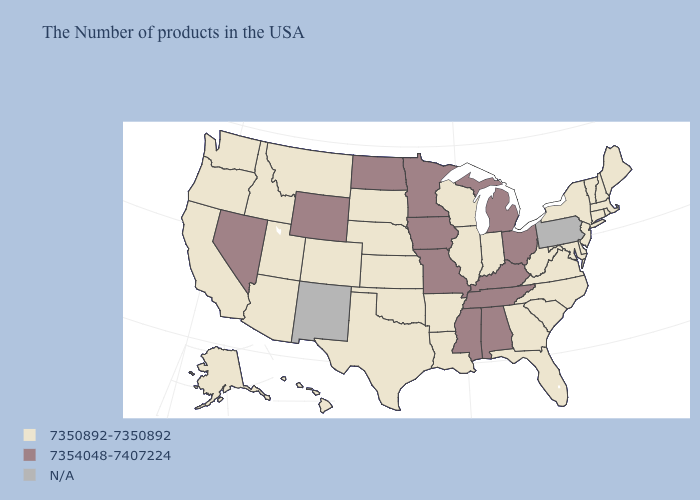Name the states that have a value in the range 7350892-7350892?
Quick response, please. Maine, Massachusetts, Rhode Island, New Hampshire, Vermont, Connecticut, New York, New Jersey, Delaware, Maryland, Virginia, North Carolina, South Carolina, West Virginia, Florida, Georgia, Indiana, Wisconsin, Illinois, Louisiana, Arkansas, Kansas, Nebraska, Oklahoma, Texas, South Dakota, Colorado, Utah, Montana, Arizona, Idaho, California, Washington, Oregon, Alaska, Hawaii. What is the value of Florida?
Short answer required. 7350892-7350892. What is the lowest value in states that border Connecticut?
Be succinct. 7350892-7350892. Which states have the highest value in the USA?
Be succinct. Ohio, Michigan, Kentucky, Alabama, Tennessee, Mississippi, Missouri, Minnesota, Iowa, North Dakota, Wyoming, Nevada. Among the states that border Michigan , which have the lowest value?
Answer briefly. Indiana, Wisconsin. Name the states that have a value in the range N/A?
Concise answer only. Pennsylvania, New Mexico. Among the states that border Idaho , does Utah have the highest value?
Be succinct. No. Name the states that have a value in the range N/A?
Write a very short answer. Pennsylvania, New Mexico. Name the states that have a value in the range 7354048-7407224?
Keep it brief. Ohio, Michigan, Kentucky, Alabama, Tennessee, Mississippi, Missouri, Minnesota, Iowa, North Dakota, Wyoming, Nevada. What is the value of Iowa?
Quick response, please. 7354048-7407224. What is the value of New Jersey?
Write a very short answer. 7350892-7350892. Name the states that have a value in the range N/A?
Be succinct. Pennsylvania, New Mexico. Does the map have missing data?
Give a very brief answer. Yes. 